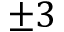Convert formula to latex. <formula><loc_0><loc_0><loc_500><loc_500>\pm 3</formula> 